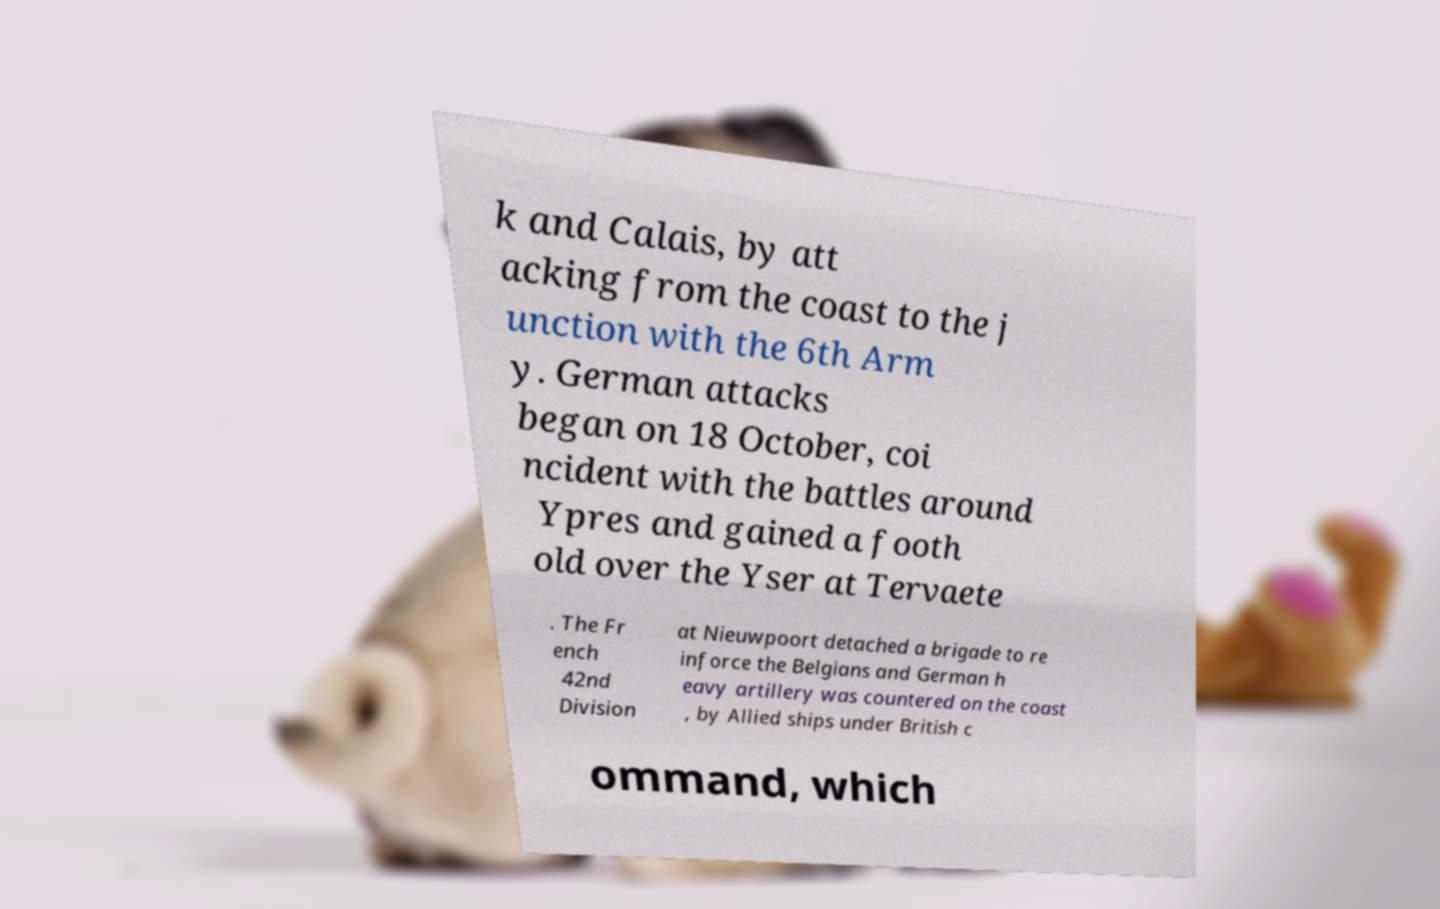Please identify and transcribe the text found in this image. k and Calais, by att acking from the coast to the j unction with the 6th Arm y. German attacks began on 18 October, coi ncident with the battles around Ypres and gained a footh old over the Yser at Tervaete . The Fr ench 42nd Division at Nieuwpoort detached a brigade to re inforce the Belgians and German h eavy artillery was countered on the coast , by Allied ships under British c ommand, which 